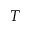<formula> <loc_0><loc_0><loc_500><loc_500>T</formula> 